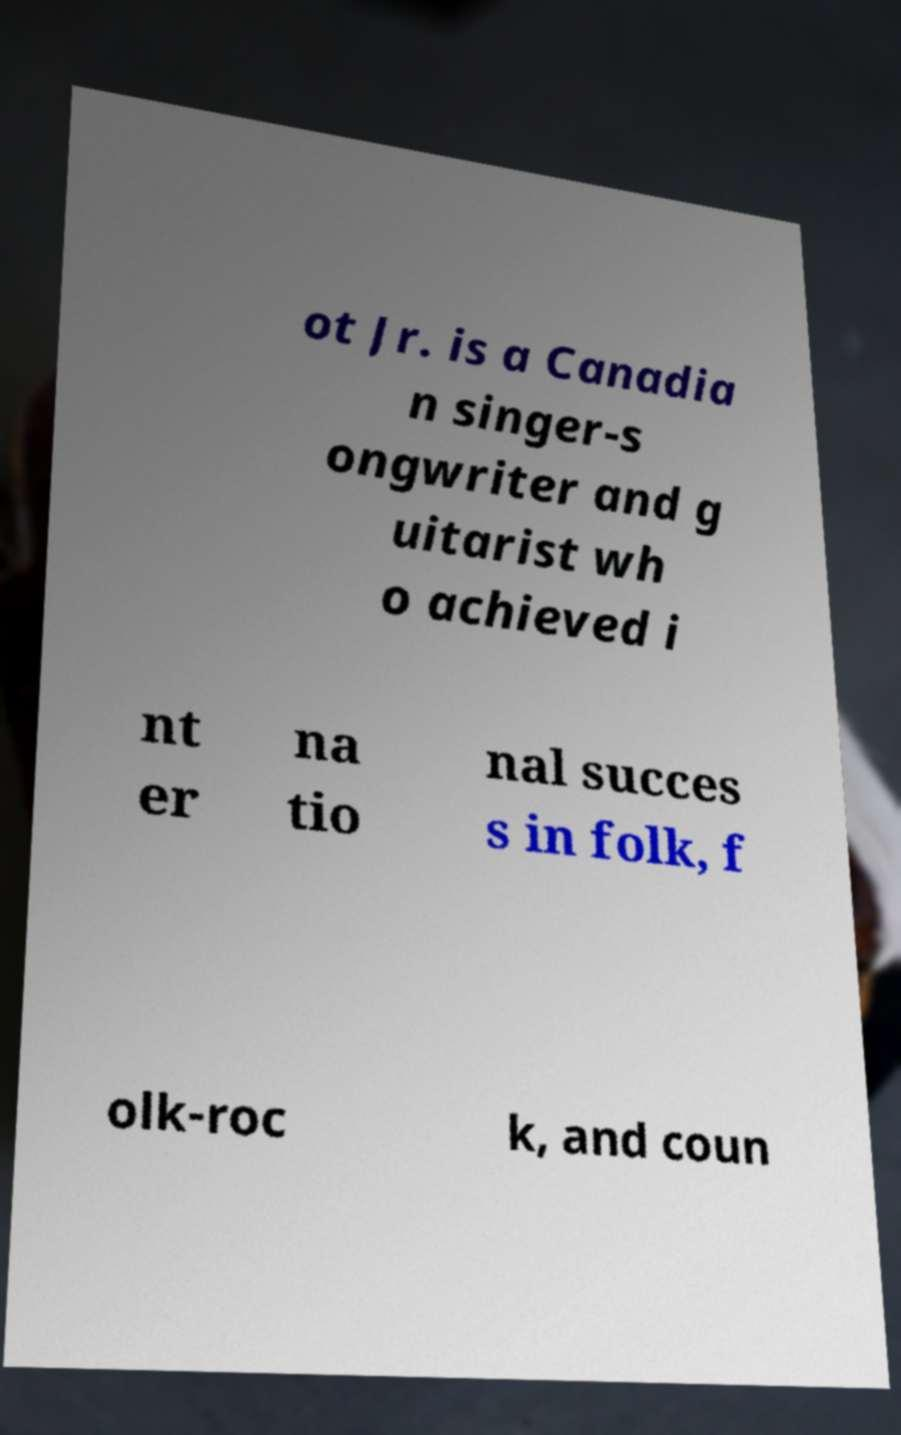What messages or text are displayed in this image? I need them in a readable, typed format. ot Jr. is a Canadia n singer-s ongwriter and g uitarist wh o achieved i nt er na tio nal succes s in folk, f olk-roc k, and coun 